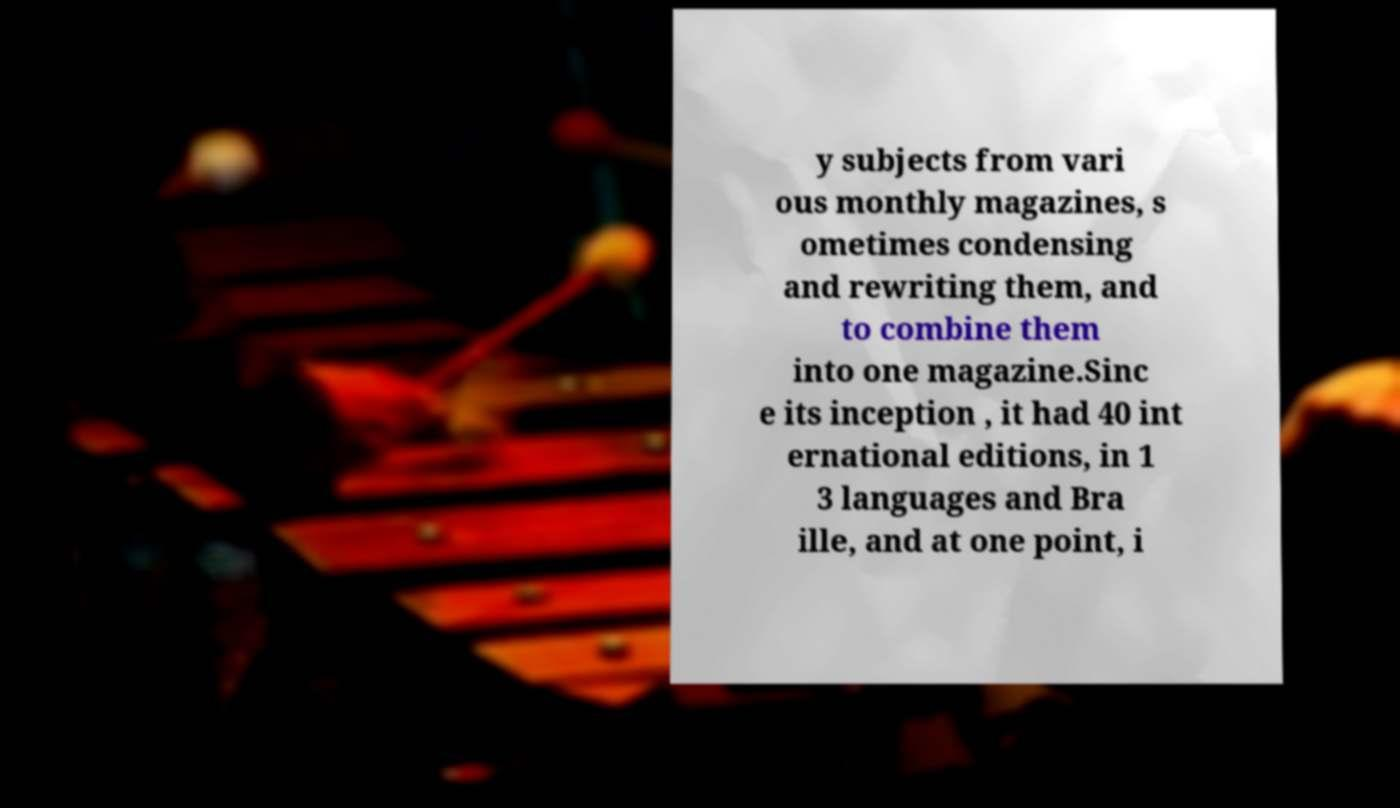For documentation purposes, I need the text within this image transcribed. Could you provide that? y subjects from vari ous monthly magazines, s ometimes condensing and rewriting them, and to combine them into one magazine.Sinc e its inception , it had 40 int ernational editions, in 1 3 languages and Bra ille, and at one point, i 